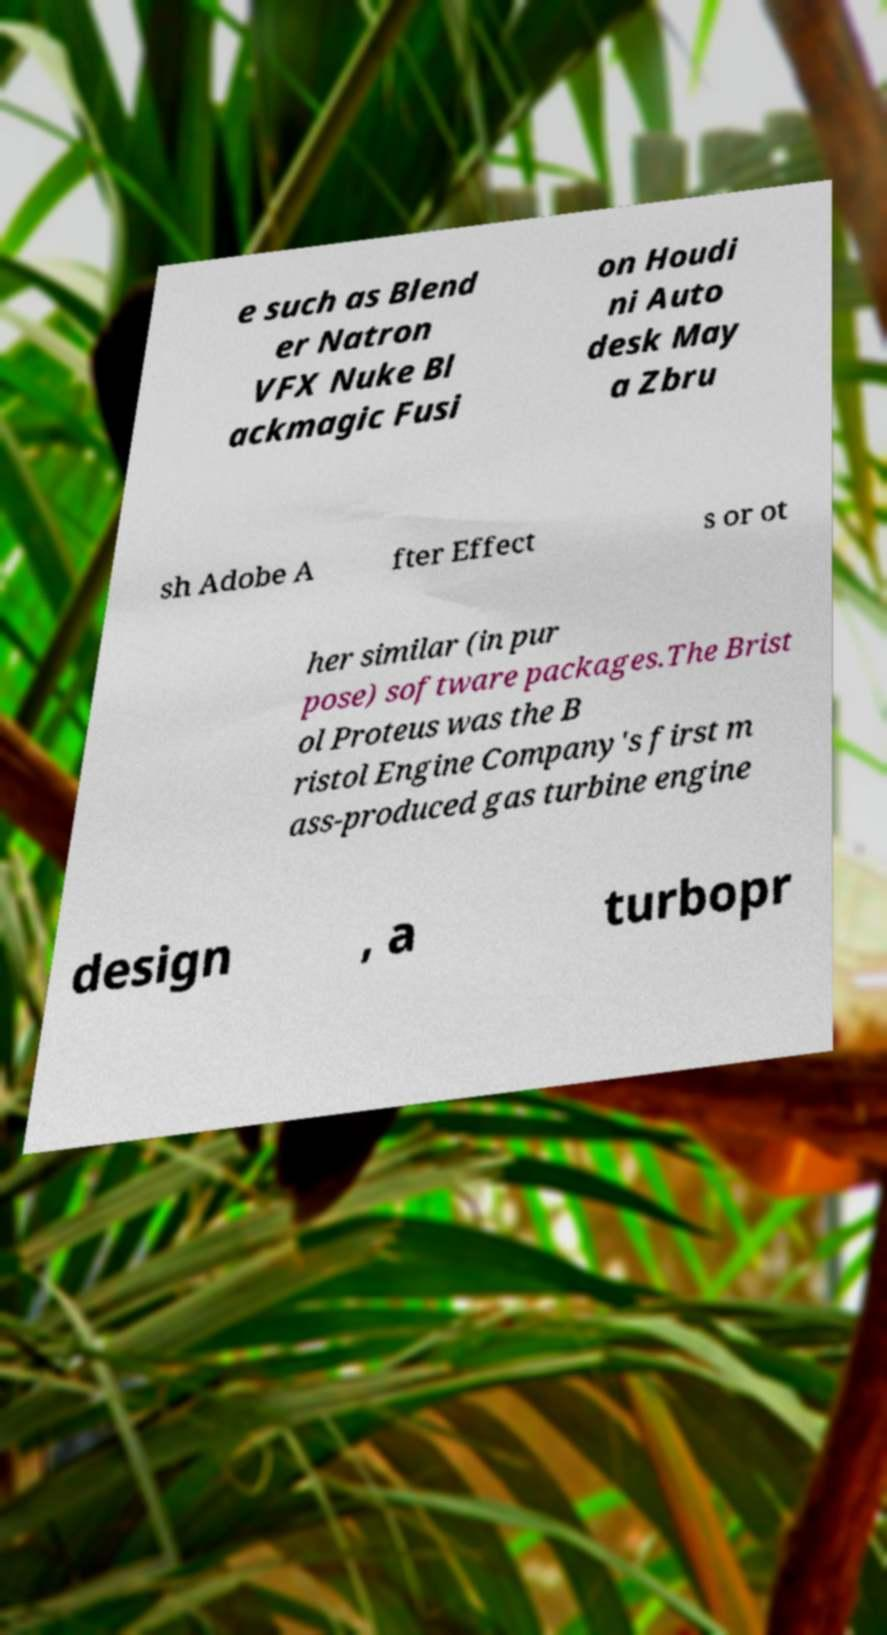Could you extract and type out the text from this image? e such as Blend er Natron VFX Nuke Bl ackmagic Fusi on Houdi ni Auto desk May a Zbru sh Adobe A fter Effect s or ot her similar (in pur pose) software packages.The Brist ol Proteus was the B ristol Engine Company's first m ass-produced gas turbine engine design , a turbopr 